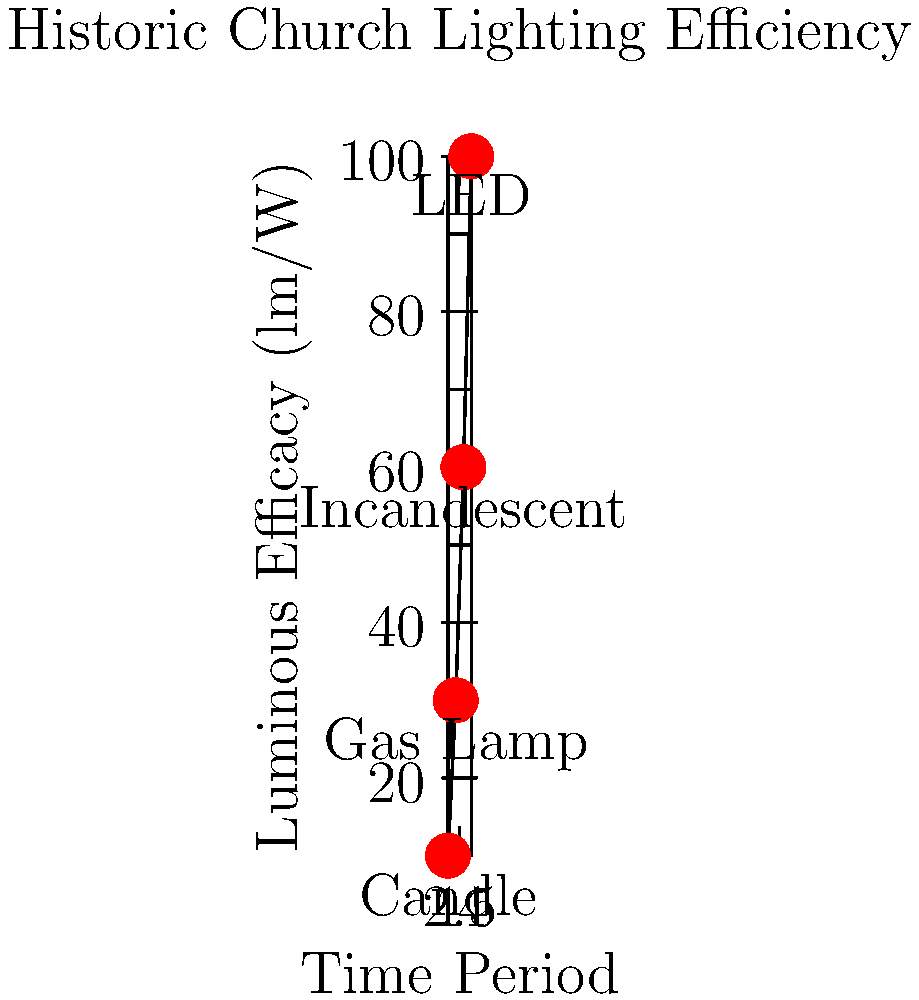Based on your experience and historical knowledge of church lighting, which type of lighting technology shown in the graph would have been most prevalent during your youth in this church, and how does its efficiency compare to modern LED lighting? Let's analyze this graph step-by-step:

1. The graph shows the luminous efficacy (light output per unit of power) of different lighting technologies used in churches over time.

2. The technologies shown are:
   - Candles: earliest form, lowest efficacy
   - Gas lamps: improved efficacy over candles
   - Incandescent bulbs: significant improvement over gas lamps
   - LED: modern technology with the highest efficacy

3. Given the persona of an elder historian who attended the church in his youth, we can assume this was likely in the mid-20th century.

4. During this period, incandescent bulbs were the most common electric lighting technology.

5. The graph shows that incandescent bulbs have an efficacy of about 60 lm/W (lumens per watt).

6. In comparison, modern LED lighting has an efficacy of about 100 lm/W.

7. This means that LED lighting is approximately $\frac{100}{60} \approx 1.67$ times more efficient than the incandescent lighting likely used during the historian's youth.
Answer: Incandescent; LED is about 67% more efficient. 